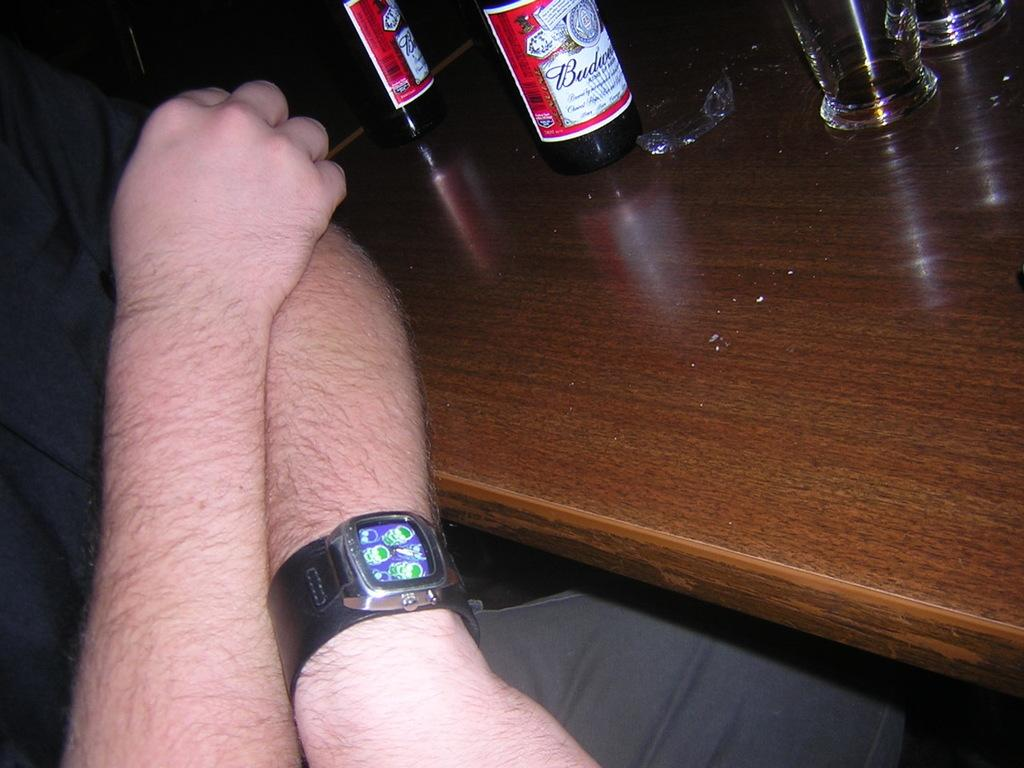<image>
Create a compact narrative representing the image presented. A Budweiser label can be seen on a table. 